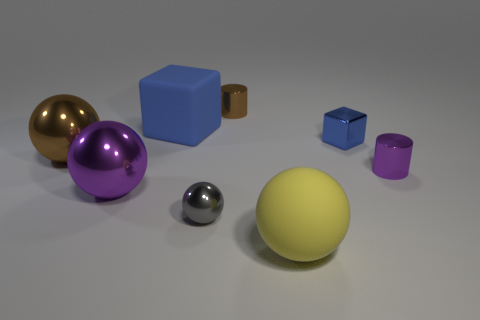What is the material of the other cube that is the same color as the big rubber block?
Your answer should be very brief. Metal. There is a cylinder that is behind the small cylinder that is to the right of the brown metal cylinder; are there any small blue metal things that are behind it?
Provide a short and direct response. No. Is the number of rubber balls to the left of the large matte cube less than the number of big shiny objects that are on the right side of the blue shiny cube?
Offer a terse response. No. What is the color of the tiny ball that is made of the same material as the large purple ball?
Provide a succinct answer. Gray. There is a ball to the right of the small cylinder behind the blue rubber object; what is its color?
Keep it short and to the point. Yellow. Are there any rubber balls of the same color as the big block?
Your answer should be compact. No. What shape is the blue thing that is the same size as the gray shiny sphere?
Your response must be concise. Cube. There is a big metallic thing in front of the small purple metal cylinder; how many big brown metallic objects are to the right of it?
Provide a short and direct response. 0. Do the small shiny cube and the big cube have the same color?
Give a very brief answer. Yes. What number of other things are there of the same material as the small block
Keep it short and to the point. 5. 